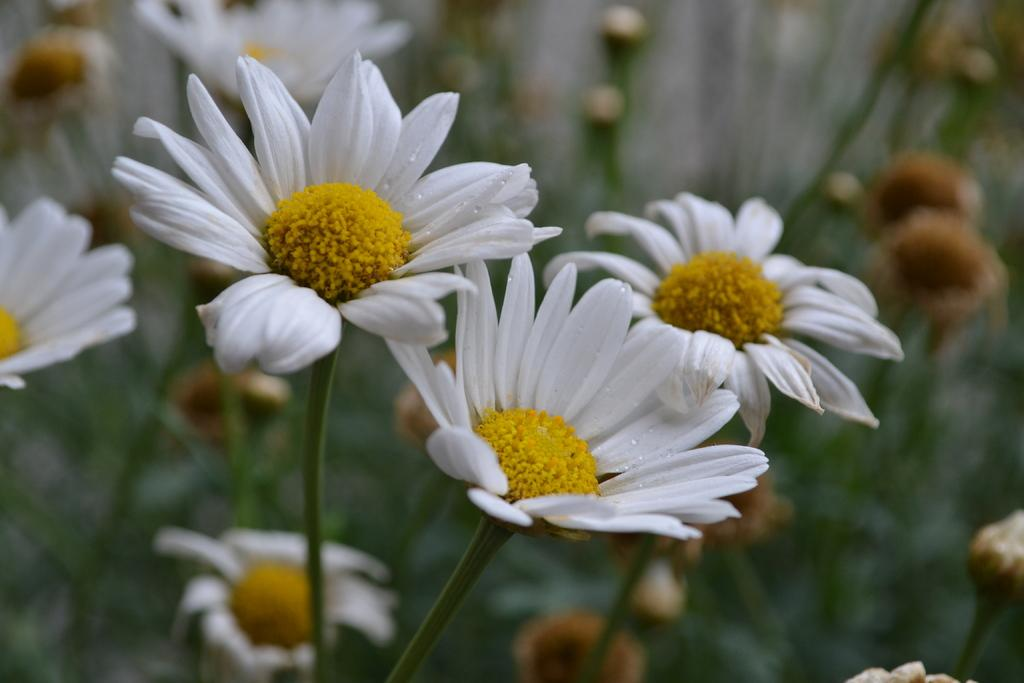What type of plant is visible in the image? There are flowers on the stem of a plant in the image. Can you describe the flowers on the plant? The flowers are visible on the stem of the plant in the image. What type of tiger can be seen in the image? There is no tiger present in the image; it features a plant with flowers on its stem. Is the plant in a pot in the image? The provided facts do not mention a pot, so we cannot determine if the plant is in a pot or not. 